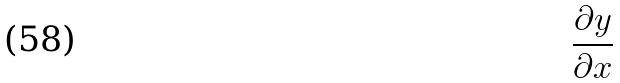Convert formula to latex. <formula><loc_0><loc_0><loc_500><loc_500>\frac { \partial y } { \partial x }</formula> 